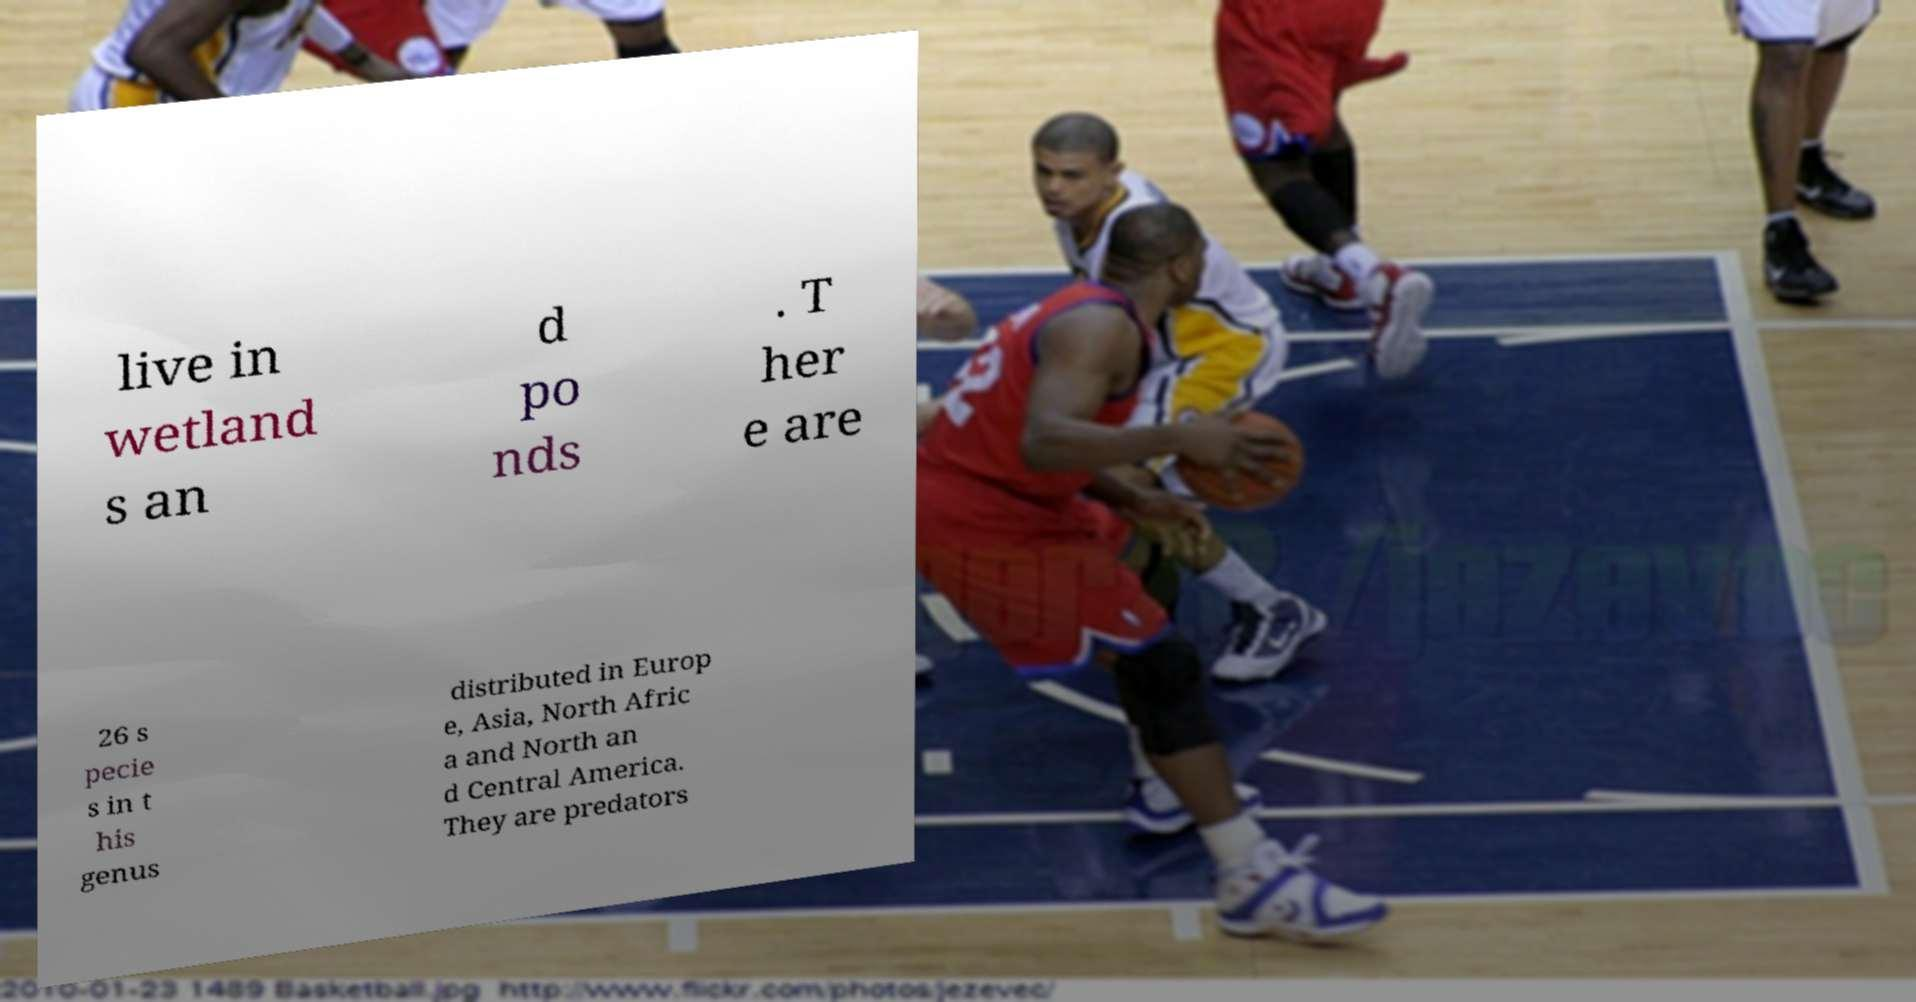What messages or text are displayed in this image? I need them in a readable, typed format. live in wetland s an d po nds . T her e are 26 s pecie s in t his genus distributed in Europ e, Asia, North Afric a and North an d Central America. They are predators 